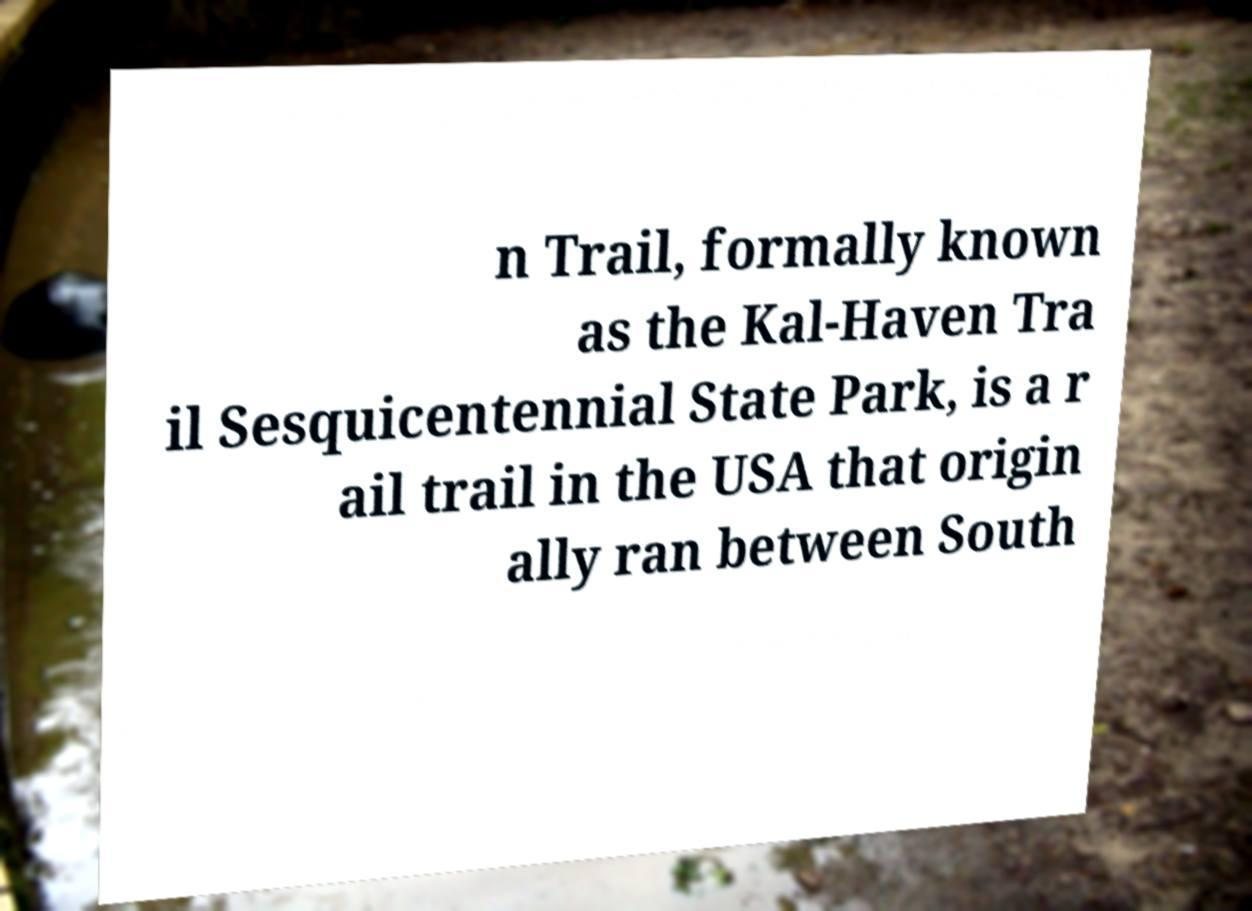Could you extract and type out the text from this image? n Trail, formally known as the Kal-Haven Tra il Sesquicentennial State Park, is a r ail trail in the USA that origin ally ran between South 